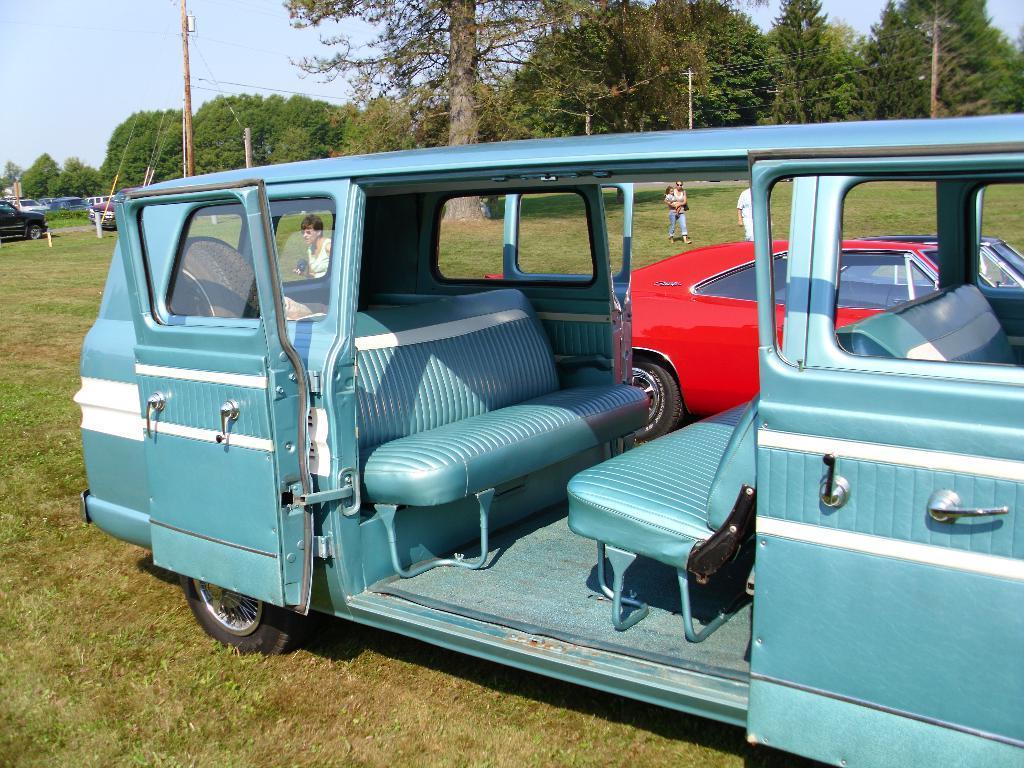Could you give a brief overview of what you see in this image? In the foreground of this picture, there is a blue van with opened door is on the grass. In the background, there is a red car, few persons walking on the grass, trees, poles,vehicles and the sky. 